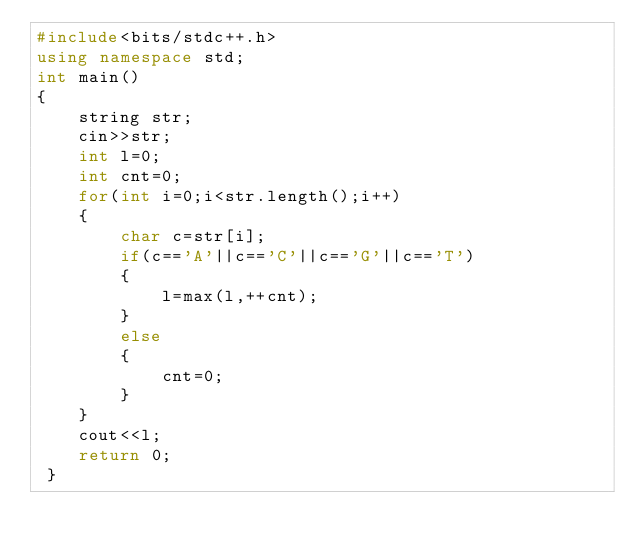Convert code to text. <code><loc_0><loc_0><loc_500><loc_500><_C++_>#include<bits/stdc++.h>
using namespace std;
int main()
{
	string str;
	cin>>str;
	int l=0;
	int cnt=0;
	for(int i=0;i<str.length();i++)
	{
		char c=str[i];
		if(c=='A'||c=='C'||c=='G'||c=='T')
		{
			l=max(l,++cnt);
		}
		else
		{
			cnt=0;
		}
	} 
	cout<<l;
	return 0;
 } </code> 